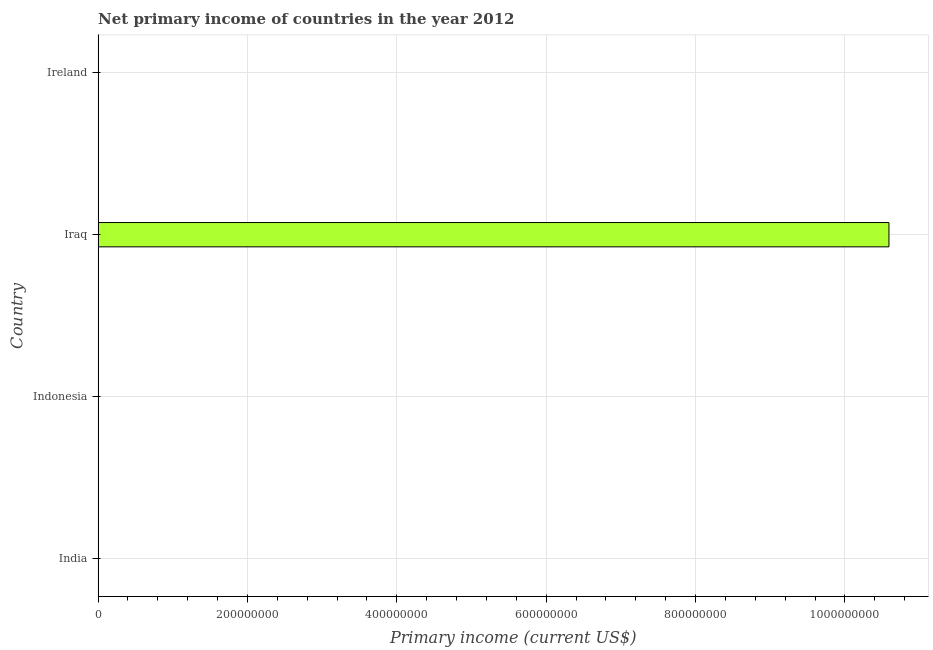Does the graph contain any zero values?
Provide a short and direct response. Yes. Does the graph contain grids?
Your response must be concise. Yes. What is the title of the graph?
Make the answer very short. Net primary income of countries in the year 2012. What is the label or title of the X-axis?
Offer a very short reply. Primary income (current US$). Across all countries, what is the maximum amount of primary income?
Ensure brevity in your answer.  1.06e+09. Across all countries, what is the minimum amount of primary income?
Make the answer very short. 0. In which country was the amount of primary income maximum?
Keep it short and to the point. Iraq. What is the sum of the amount of primary income?
Your answer should be compact. 1.06e+09. What is the average amount of primary income per country?
Offer a very short reply. 2.65e+08. In how many countries, is the amount of primary income greater than 1040000000 US$?
Provide a short and direct response. 1. What is the difference between the highest and the lowest amount of primary income?
Keep it short and to the point. 1.06e+09. In how many countries, is the amount of primary income greater than the average amount of primary income taken over all countries?
Make the answer very short. 1. How many bars are there?
Your answer should be compact. 1. How many countries are there in the graph?
Ensure brevity in your answer.  4. Are the values on the major ticks of X-axis written in scientific E-notation?
Provide a succinct answer. No. What is the Primary income (current US$) in Indonesia?
Give a very brief answer. 0. What is the Primary income (current US$) in Iraq?
Offer a terse response. 1.06e+09. 